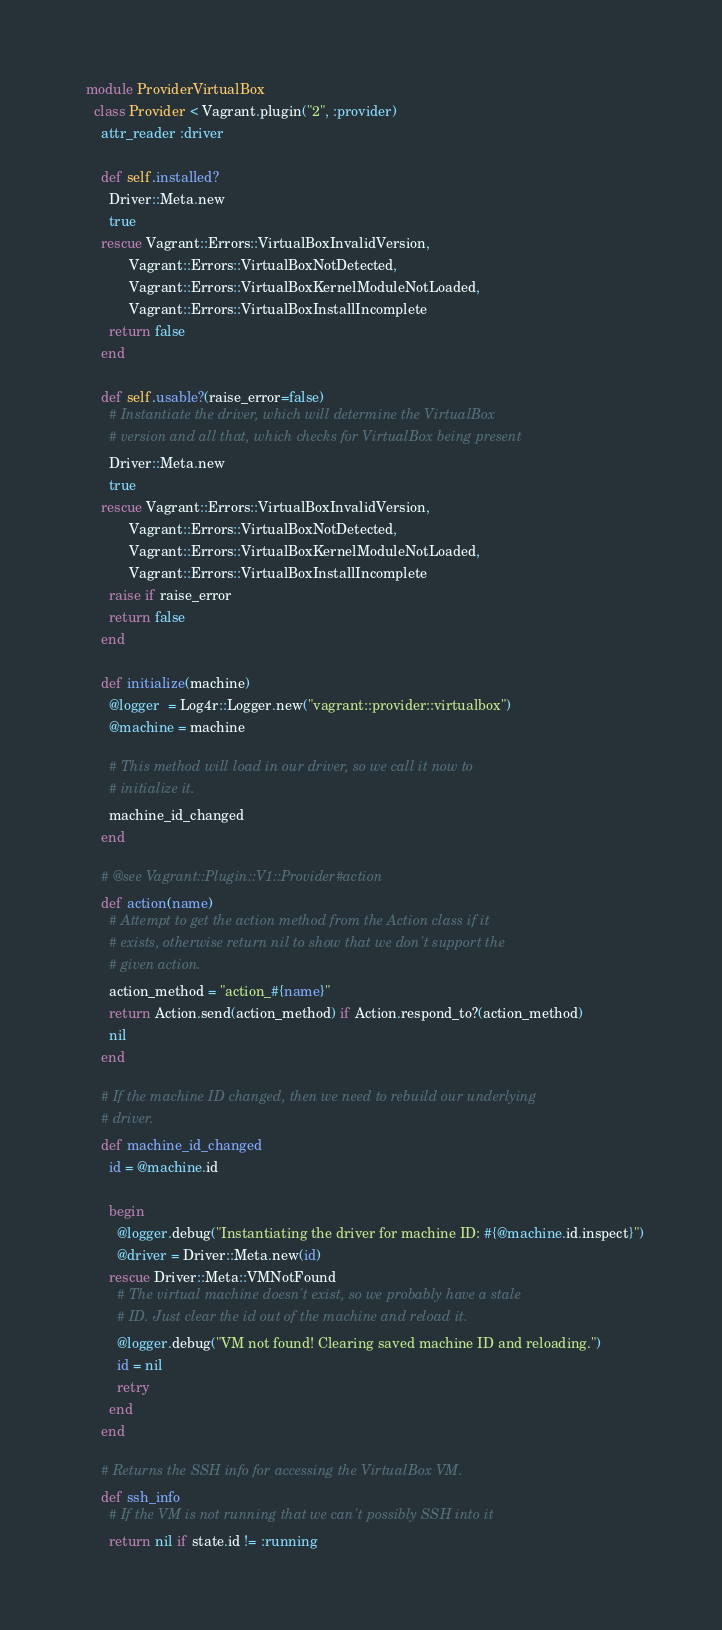<code> <loc_0><loc_0><loc_500><loc_500><_Ruby_>  module ProviderVirtualBox
    class Provider < Vagrant.plugin("2", :provider)
      attr_reader :driver

      def self.installed?
        Driver::Meta.new
        true
      rescue Vagrant::Errors::VirtualBoxInvalidVersion,
             Vagrant::Errors::VirtualBoxNotDetected,
             Vagrant::Errors::VirtualBoxKernelModuleNotLoaded,
             Vagrant::Errors::VirtualBoxInstallIncomplete
        return false
      end

      def self.usable?(raise_error=false)
        # Instantiate the driver, which will determine the VirtualBox
        # version and all that, which checks for VirtualBox being present
        Driver::Meta.new
        true
      rescue Vagrant::Errors::VirtualBoxInvalidVersion,
             Vagrant::Errors::VirtualBoxNotDetected,
             Vagrant::Errors::VirtualBoxKernelModuleNotLoaded,
             Vagrant::Errors::VirtualBoxInstallIncomplete
        raise if raise_error
        return false
      end

      def initialize(machine)
        @logger  = Log4r::Logger.new("vagrant::provider::virtualbox")
        @machine = machine

        # This method will load in our driver, so we call it now to
        # initialize it.
        machine_id_changed
      end

      # @see Vagrant::Plugin::V1::Provider#action
      def action(name)
        # Attempt to get the action method from the Action class if it
        # exists, otherwise return nil to show that we don't support the
        # given action.
        action_method = "action_#{name}"
        return Action.send(action_method) if Action.respond_to?(action_method)
        nil
      end

      # If the machine ID changed, then we need to rebuild our underlying
      # driver.
      def machine_id_changed
        id = @machine.id

        begin
          @logger.debug("Instantiating the driver for machine ID: #{@machine.id.inspect}")
          @driver = Driver::Meta.new(id)
        rescue Driver::Meta::VMNotFound
          # The virtual machine doesn't exist, so we probably have a stale
          # ID. Just clear the id out of the machine and reload it.
          @logger.debug("VM not found! Clearing saved machine ID and reloading.")
          id = nil
          retry
        end
      end

      # Returns the SSH info for accessing the VirtualBox VM.
      def ssh_info
        # If the VM is not running that we can't possibly SSH into it
        return nil if state.id != :running
</code> 